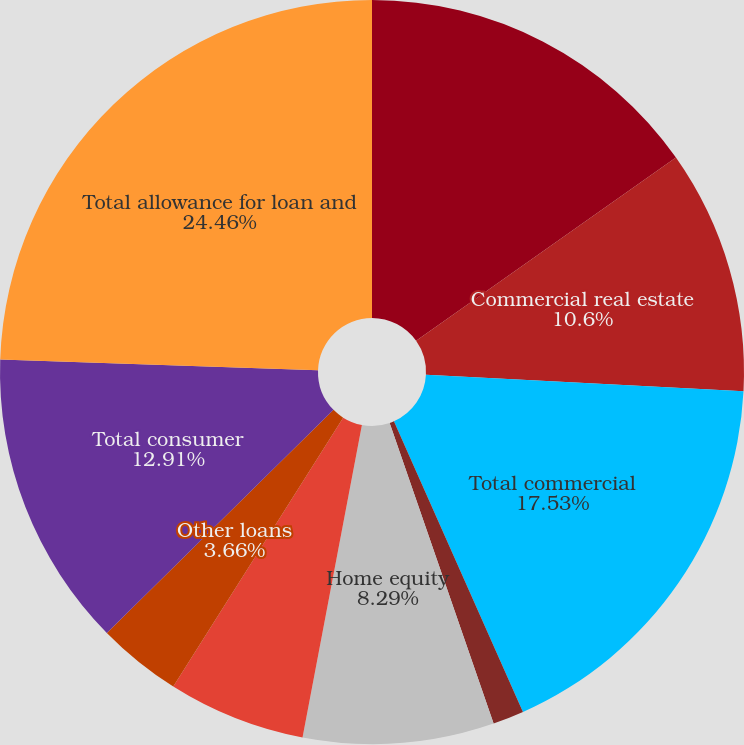Convert chart. <chart><loc_0><loc_0><loc_500><loc_500><pie_chart><fcel>Commercial and industrial<fcel>Commercial real estate<fcel>Total commercial<fcel>Automobile<fcel>Home equity<fcel>Residential mortgage<fcel>Other loans<fcel>Total consumer<fcel>Total allowance for loan and<nl><fcel>15.22%<fcel>10.6%<fcel>17.53%<fcel>1.35%<fcel>8.29%<fcel>5.98%<fcel>3.66%<fcel>12.91%<fcel>24.46%<nl></chart> 